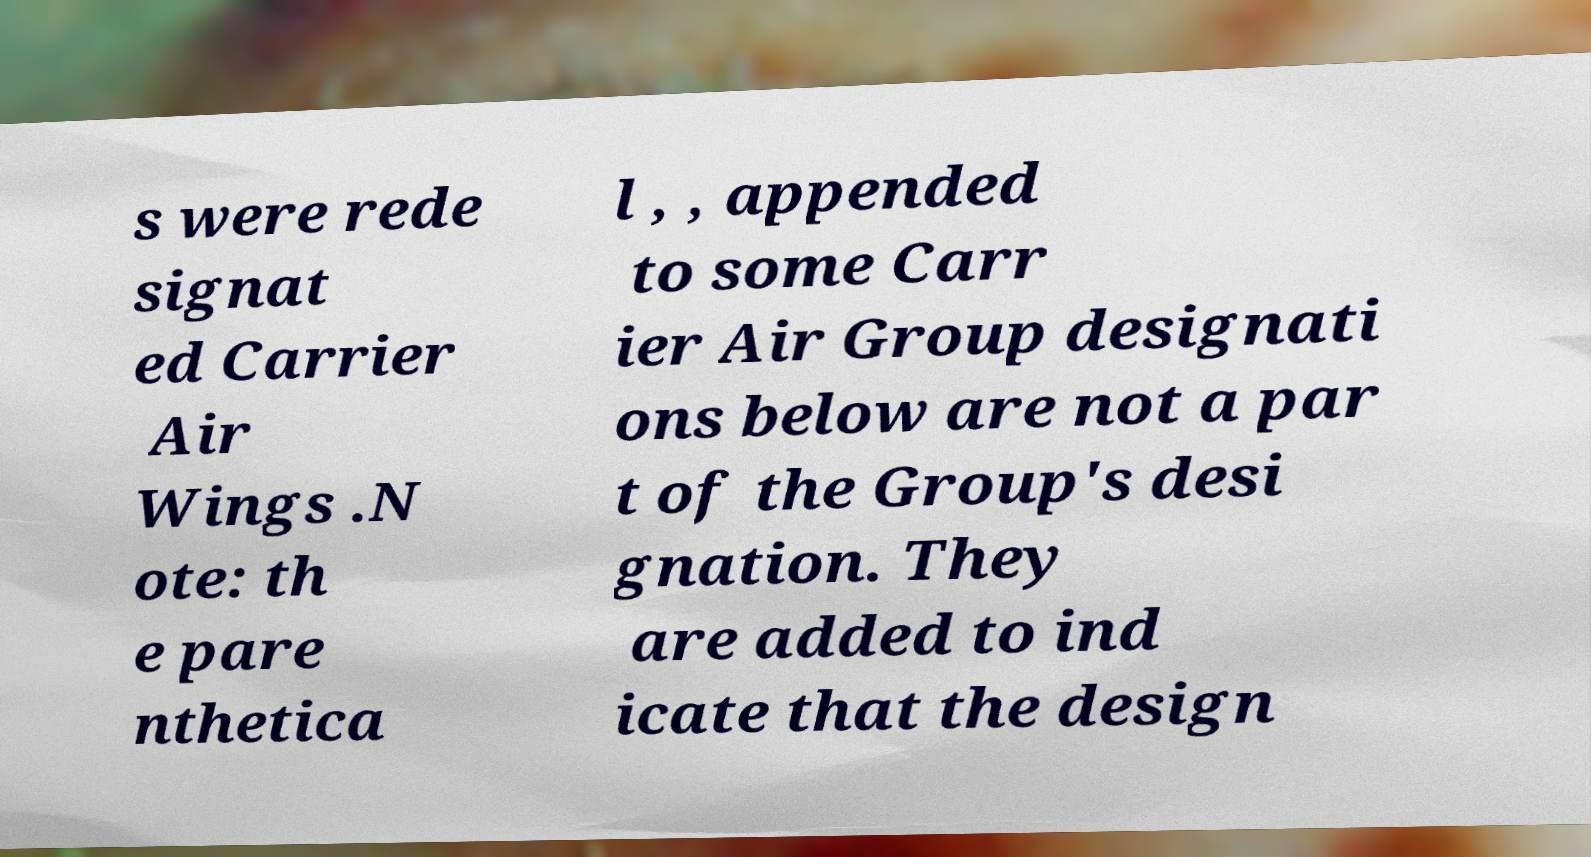For documentation purposes, I need the text within this image transcribed. Could you provide that? s were rede signat ed Carrier Air Wings .N ote: th e pare nthetica l , , appended to some Carr ier Air Group designati ons below are not a par t of the Group's desi gnation. They are added to ind icate that the design 